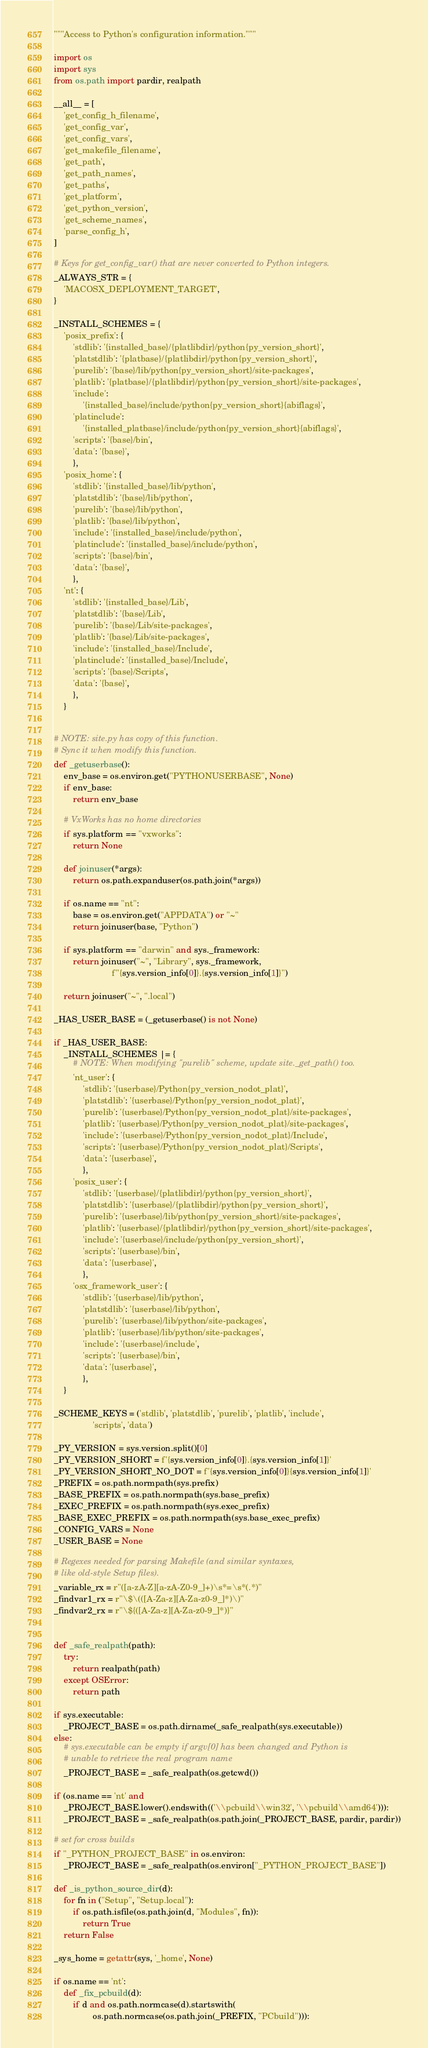<code> <loc_0><loc_0><loc_500><loc_500><_Python_>"""Access to Python's configuration information."""

import os
import sys
from os.path import pardir, realpath

__all__ = [
    'get_config_h_filename',
    'get_config_var',
    'get_config_vars',
    'get_makefile_filename',
    'get_path',
    'get_path_names',
    'get_paths',
    'get_platform',
    'get_python_version',
    'get_scheme_names',
    'parse_config_h',
]

# Keys for get_config_var() that are never converted to Python integers.
_ALWAYS_STR = {
    'MACOSX_DEPLOYMENT_TARGET',
}

_INSTALL_SCHEMES = {
    'posix_prefix': {
        'stdlib': '{installed_base}/{platlibdir}/python{py_version_short}',
        'platstdlib': '{platbase}/{platlibdir}/python{py_version_short}',
        'purelib': '{base}/lib/python{py_version_short}/site-packages',
        'platlib': '{platbase}/{platlibdir}/python{py_version_short}/site-packages',
        'include':
            '{installed_base}/include/python{py_version_short}{abiflags}',
        'platinclude':
            '{installed_platbase}/include/python{py_version_short}{abiflags}',
        'scripts': '{base}/bin',
        'data': '{base}',
        },
    'posix_home': {
        'stdlib': '{installed_base}/lib/python',
        'platstdlib': '{base}/lib/python',
        'purelib': '{base}/lib/python',
        'platlib': '{base}/lib/python',
        'include': '{installed_base}/include/python',
        'platinclude': '{installed_base}/include/python',
        'scripts': '{base}/bin',
        'data': '{base}',
        },
    'nt': {
        'stdlib': '{installed_base}/Lib',
        'platstdlib': '{base}/Lib',
        'purelib': '{base}/Lib/site-packages',
        'platlib': '{base}/Lib/site-packages',
        'include': '{installed_base}/Include',
        'platinclude': '{installed_base}/Include',
        'scripts': '{base}/Scripts',
        'data': '{base}',
        },
    }


# NOTE: site.py has copy of this function.
# Sync it when modify this function.
def _getuserbase():
    env_base = os.environ.get("PYTHONUSERBASE", None)
    if env_base:
        return env_base

    # VxWorks has no home directories
    if sys.platform == "vxworks":
        return None

    def joinuser(*args):
        return os.path.expanduser(os.path.join(*args))

    if os.name == "nt":
        base = os.environ.get("APPDATA") or "~"
        return joinuser(base, "Python")

    if sys.platform == "darwin" and sys._framework:
        return joinuser("~", "Library", sys._framework,
                        f"{sys.version_info[0]}.{sys.version_info[1]}")

    return joinuser("~", ".local")

_HAS_USER_BASE = (_getuserbase() is not None)

if _HAS_USER_BASE:
    _INSTALL_SCHEMES |= {
        # NOTE: When modifying "purelib" scheme, update site._get_path() too.
        'nt_user': {
            'stdlib': '{userbase}/Python{py_version_nodot_plat}',
            'platstdlib': '{userbase}/Python{py_version_nodot_plat}',
            'purelib': '{userbase}/Python{py_version_nodot_plat}/site-packages',
            'platlib': '{userbase}/Python{py_version_nodot_plat}/site-packages',
            'include': '{userbase}/Python{py_version_nodot_plat}/Include',
            'scripts': '{userbase}/Python{py_version_nodot_plat}/Scripts',
            'data': '{userbase}',
            },
        'posix_user': {
            'stdlib': '{userbase}/{platlibdir}/python{py_version_short}',
            'platstdlib': '{userbase}/{platlibdir}/python{py_version_short}',
            'purelib': '{userbase}/lib/python{py_version_short}/site-packages',
            'platlib': '{userbase}/{platlibdir}/python{py_version_short}/site-packages',
            'include': '{userbase}/include/python{py_version_short}',
            'scripts': '{userbase}/bin',
            'data': '{userbase}',
            },
        'osx_framework_user': {
            'stdlib': '{userbase}/lib/python',
            'platstdlib': '{userbase}/lib/python',
            'purelib': '{userbase}/lib/python/site-packages',
            'platlib': '{userbase}/lib/python/site-packages',
            'include': '{userbase}/include',
            'scripts': '{userbase}/bin',
            'data': '{userbase}',
            },
    }

_SCHEME_KEYS = ('stdlib', 'platstdlib', 'purelib', 'platlib', 'include',
                'scripts', 'data')

_PY_VERSION = sys.version.split()[0]
_PY_VERSION_SHORT = f'{sys.version_info[0]}.{sys.version_info[1]}'
_PY_VERSION_SHORT_NO_DOT = f'{sys.version_info[0]}{sys.version_info[1]}'
_PREFIX = os.path.normpath(sys.prefix)
_BASE_PREFIX = os.path.normpath(sys.base_prefix)
_EXEC_PREFIX = os.path.normpath(sys.exec_prefix)
_BASE_EXEC_PREFIX = os.path.normpath(sys.base_exec_prefix)
_CONFIG_VARS = None
_USER_BASE = None

# Regexes needed for parsing Makefile (and similar syntaxes,
# like old-style Setup files).
_variable_rx = r"([a-zA-Z][a-zA-Z0-9_]+)\s*=\s*(.*)"
_findvar1_rx = r"\$\(([A-Za-z][A-Za-z0-9_]*)\)"
_findvar2_rx = r"\${([A-Za-z][A-Za-z0-9_]*)}"


def _safe_realpath(path):
    try:
        return realpath(path)
    except OSError:
        return path

if sys.executable:
    _PROJECT_BASE = os.path.dirname(_safe_realpath(sys.executable))
else:
    # sys.executable can be empty if argv[0] has been changed and Python is
    # unable to retrieve the real program name
    _PROJECT_BASE = _safe_realpath(os.getcwd())

if (os.name == 'nt' and
    _PROJECT_BASE.lower().endswith(('\\pcbuild\\win32', '\\pcbuild\\amd64'))):
    _PROJECT_BASE = _safe_realpath(os.path.join(_PROJECT_BASE, pardir, pardir))

# set for cross builds
if "_PYTHON_PROJECT_BASE" in os.environ:
    _PROJECT_BASE = _safe_realpath(os.environ["_PYTHON_PROJECT_BASE"])

def _is_python_source_dir(d):
    for fn in ("Setup", "Setup.local"):
        if os.path.isfile(os.path.join(d, "Modules", fn)):
            return True
    return False

_sys_home = getattr(sys, '_home', None)

if os.name == 'nt':
    def _fix_pcbuild(d):
        if d and os.path.normcase(d).startswith(
                os.path.normcase(os.path.join(_PREFIX, "PCbuild"))):</code> 